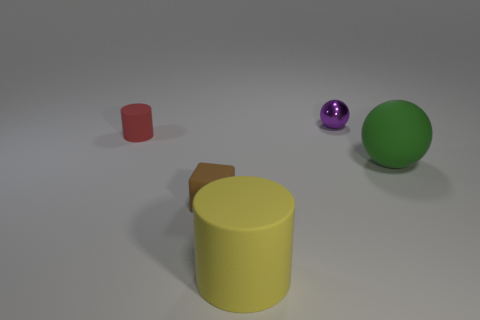Add 5 large blue matte cylinders. How many objects exist? 10 Subtract all balls. How many objects are left? 3 Subtract 1 red cylinders. How many objects are left? 4 Subtract all tiny brown metallic things. Subtract all tiny purple shiny objects. How many objects are left? 4 Add 4 yellow matte objects. How many yellow matte objects are left? 5 Add 4 large yellow cylinders. How many large yellow cylinders exist? 5 